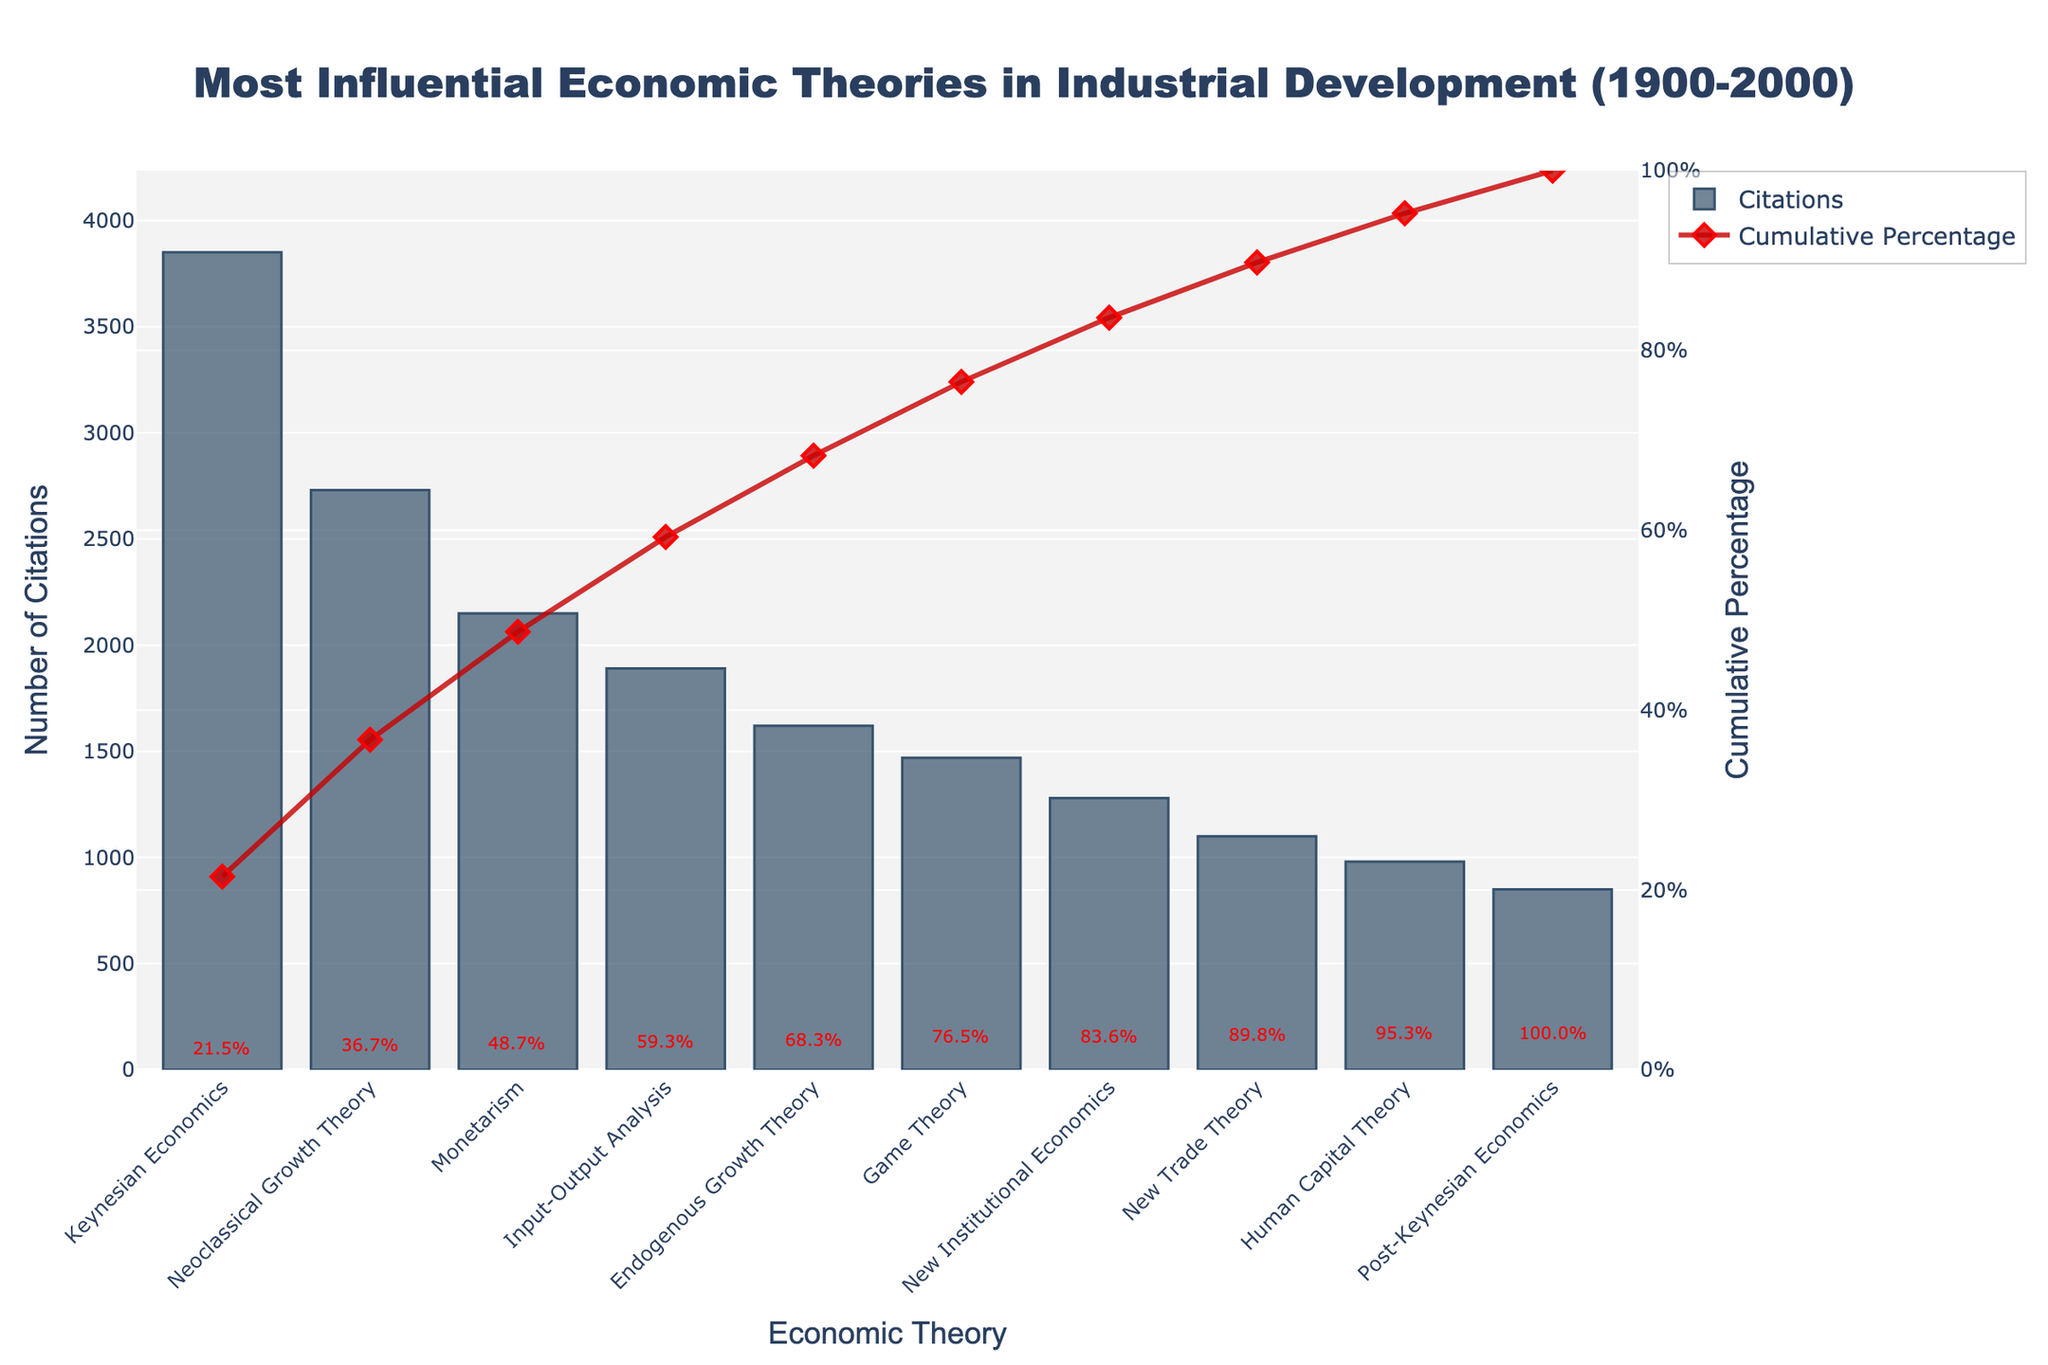Which economic theory has the highest citation count? The Pareto chart shows bars representing citations of different economic theories. By looking at the highest bar, we see that Keynesian Economics has the most citations.
Answer: Keynesian Economics What is the cumulative percentage of citations for the top three theories? To find the cumulative percentage, add the Citations for Keynesian Economics, Neoclassical Growth Theory, and Monetarism: (3850 + 2730 + 2150 = 8730). Then divide 8730 by the total citations and multiply by 100. The cumulative percentage line shows this sum at 64.5%.
Answer: 64.5% Which theory marks the point where over 80% of citations have been accumulated? Observing the cumulative percentage line, it surpasses 80% between New Institutional Economics and New Trade Theory, indicating New Institutional Economics as the theory where over 80% of citations are reached.
Answer: New Institutional Economics What is the difference in citation counts between Game Theory and Post-Keynesian Economics? Game Theory has 1470 citations, and Post-Keynesian Economics has 850 citations. To find the difference, subtract 850 from 1470: (1470 - 850 = 620).
Answer: 620 How many theories have more than 1500 citations? By looking at the bars representing citation counts, those taller than 1500 are Keynesian Economics, Neoclassical Growth Theory, Monetarism, Input-Output Analysis, and Endogenous Growth Theory.
Answer: 5 What is the median citation count for the given theories? List the citation counts in ascending order: [850, 980, 1100, 1280, 1470, 1620, 1890, 2150, 2730, 3850] and find the middle value. For an even number of values, the median is the average of the two middle numbers (1280 + 1470) / 2.
Answer: 1375 What percentage does Game Theory contribute to the whole? Game Theory has 1470 citations. The total citations are 19820. To find the percentage: (1470 / 19820) * 100 = 7.42%.
Answer: 7.42% What is the cumulative percentage after Neoclassical Growth Theory? The cumulative percentage is the sum of citations of Keynesian Economics and Neoclassical Growth Theory divided by the total citations, then multiplied by 100. This value is shown on the Cumulative Percentage line at 62.2%.
Answer: 62.2% How does the citation count of New Trade Theory compare to that of Human Capital Theory? New Trade Theory has 1100 citations, while Human Capital Theory has 980 citations. Comparing the numbers, New Trade Theory has more citations.
Answer: New Trade Theory 